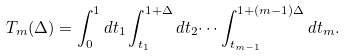Convert formula to latex. <formula><loc_0><loc_0><loc_500><loc_500>T _ { m } ( \Delta ) = \int _ { 0 } ^ { 1 } d t _ { 1 } \int _ { t _ { 1 } } ^ { 1 + \Delta } d t _ { 2 } \dots \int _ { t _ { m - 1 } } ^ { 1 + ( m - 1 ) \Delta } d t _ { m } .</formula> 